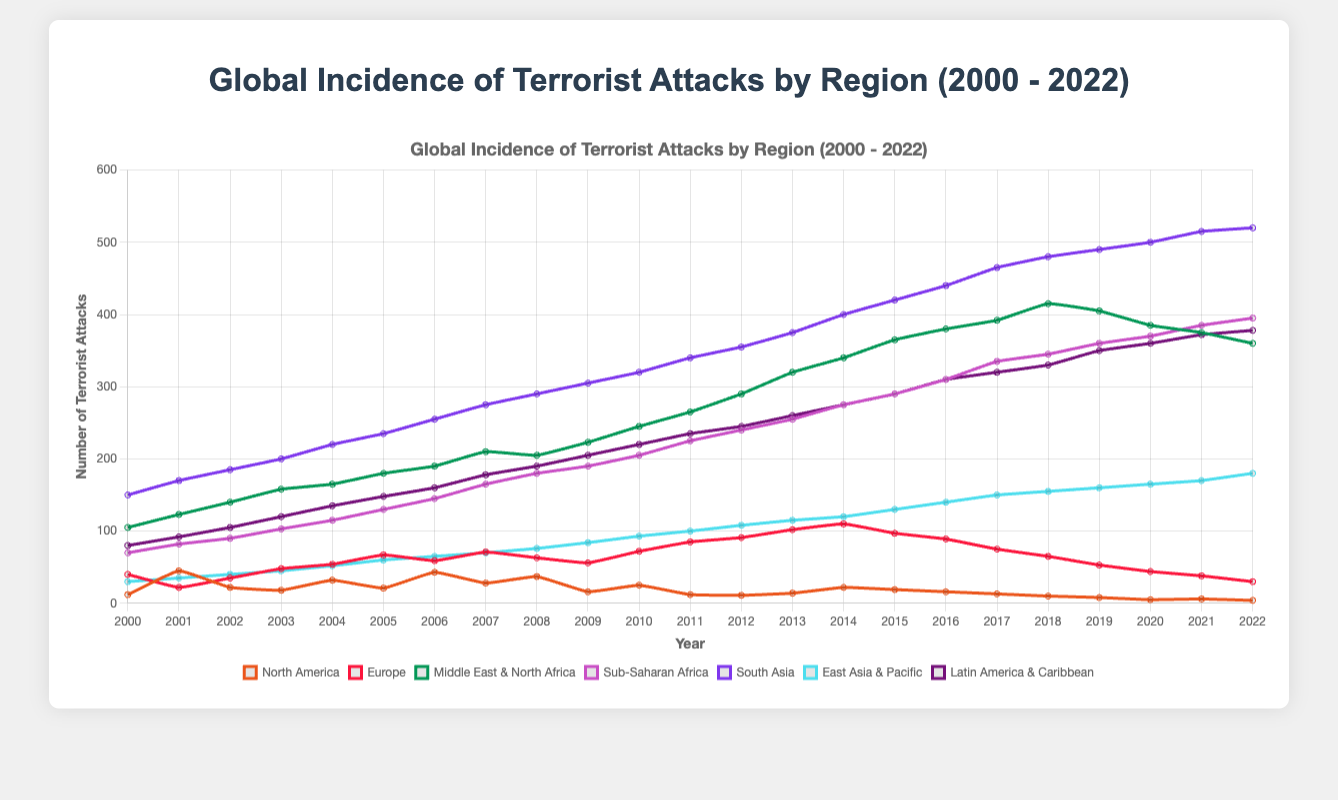What's the overall trend in terrorist attacks in the Middle East & North Africa region from 2000 to 2022? The plot shows a general upward trend in the number of terrorist attacks in the Middle East & North Africa region from 2000 to 2022. Initially, there were 105 attacks in 2000, and this number increased to its peak of 415 around 2018 before a slight decrease to 360 in 2022.
Answer: Upward trend Which region had the highest increase in terrorist attacks from 2000 to 2022? To find the region with the highest increase, we need to look at the number of attacks in 2000 and 2022 for each region and calculate the difference. South Asia had 150 attacks in 2000 and 520 in 2022, resulting in a difference of 370, which is the highest compared to other regions.
Answer: South Asia In which year did Europe experience its highest number of terrorist attacks? To identify the year with the highest number of terrorist attacks in Europe, observe the peaks in the Europe line. The peak value occurs in 2014 with 110 attacks.
Answer: 2014 Compare the trend of terrorist attacks in South Asia and Latin America & Caribbean regions. South Asia shows a steady increase in terrorist attacks from 2000 (150 attacks) to 2022 (520 attacks). Latin America & Caribbean also shows an increasing trend but with smaller numbers, starting at 80 attacks in 2000 and reaching 378 in 2022.
Answer: Steady increase in both, with South Asia having significantly higher numbers In 2020, which region experienced fewer terrorist attacks: North America or Europe? From the chart, in 2020, North America experienced 5 attacks, while Europe experienced 44 attacks. Therefore, North America experienced fewer terrorist attacks.
Answer: North America What is the general pattern of terrorist attacks in East Asia & Pacific from 2000 to 2022? The plot indicates that terrorist attacks in the East Asia & Pacific region show a generally increasing trend from 30 attacks in 2000 to 180 in 2022, with no major fluctuations.
Answer: Increasing trend What is the sum of terrorist attacks in North America in 2000 and 2022? The number of terrorist attacks in North America in 2000 is 12, and in 2022 it is 4. The sum of these attacks is 12 + 4 = 16.
Answer: 16 During which year did the Middle East & North Africa region see a decline in terrorist attacks from the previous year? Observing the trend for the Middle East & North Africa region, there is a decline from 415 attacks in 2018 to 405 attacks in 2019, showing a decrease.
Answer: 2019 Between Sub-Saharan Africa and Latin America & Caribbean, which region had more consistent yearly increases in terrorist attacks? Sub-Saharan Africa demonstrates a more consistent yearly increase in terrorist attacks from 70 in 2000 to 395 in 2022, while Latin America & Caribbean has a similar increasing trend but shows more variability.
Answer: Sub-Saharan Africa 